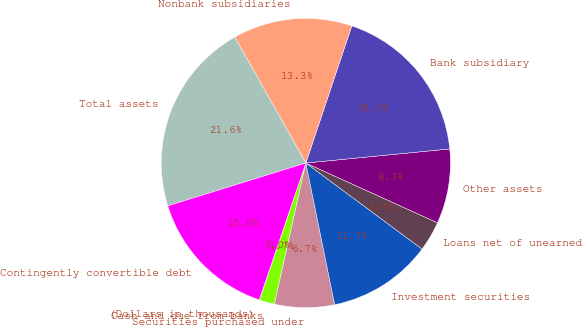Convert chart. <chart><loc_0><loc_0><loc_500><loc_500><pie_chart><fcel>(Dollars in thousands)<fcel>Cash and due from banks<fcel>Securities purchased under<fcel>Investment securities<fcel>Loans net of unearned<fcel>Other assets<fcel>Bank subsidiary<fcel>Nonbank subsidiaries<fcel>Total assets<fcel>Contingently convertible debt<nl><fcel>0.04%<fcel>1.7%<fcel>6.68%<fcel>11.66%<fcel>3.36%<fcel>8.34%<fcel>18.3%<fcel>13.32%<fcel>21.62%<fcel>14.98%<nl></chart> 